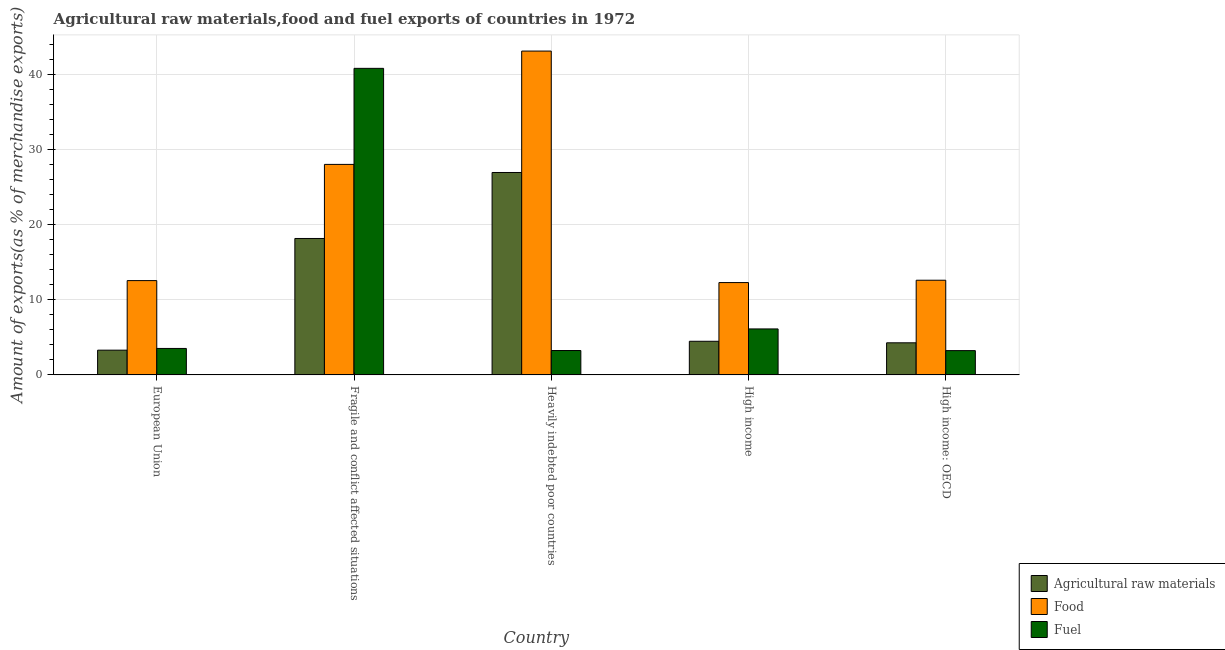How many different coloured bars are there?
Offer a terse response. 3. Are the number of bars per tick equal to the number of legend labels?
Offer a terse response. Yes. Are the number of bars on each tick of the X-axis equal?
Ensure brevity in your answer.  Yes. How many bars are there on the 4th tick from the right?
Your response must be concise. 3. What is the percentage of fuel exports in European Union?
Your response must be concise. 3.52. Across all countries, what is the maximum percentage of raw materials exports?
Your answer should be compact. 26.95. Across all countries, what is the minimum percentage of food exports?
Provide a succinct answer. 12.29. In which country was the percentage of food exports maximum?
Ensure brevity in your answer.  Heavily indebted poor countries. In which country was the percentage of raw materials exports minimum?
Your answer should be very brief. European Union. What is the total percentage of food exports in the graph?
Your response must be concise. 108.61. What is the difference between the percentage of fuel exports in European Union and that in Heavily indebted poor countries?
Provide a succinct answer. 0.28. What is the difference between the percentage of raw materials exports in European Union and the percentage of food exports in High income?
Give a very brief answer. -9. What is the average percentage of raw materials exports per country?
Your answer should be very brief. 11.43. What is the difference between the percentage of food exports and percentage of raw materials exports in High income: OECD?
Keep it short and to the point. 8.33. What is the ratio of the percentage of raw materials exports in Fragile and conflict affected situations to that in High income: OECD?
Your answer should be compact. 4.25. Is the difference between the percentage of raw materials exports in Fragile and conflict affected situations and High income: OECD greater than the difference between the percentage of food exports in Fragile and conflict affected situations and High income: OECD?
Provide a short and direct response. No. What is the difference between the highest and the second highest percentage of raw materials exports?
Offer a terse response. 8.79. What is the difference between the highest and the lowest percentage of fuel exports?
Your response must be concise. 37.59. Is the sum of the percentage of fuel exports in Heavily indebted poor countries and High income: OECD greater than the maximum percentage of food exports across all countries?
Provide a succinct answer. No. What does the 1st bar from the left in High income: OECD represents?
Ensure brevity in your answer.  Agricultural raw materials. What does the 3rd bar from the right in Fragile and conflict affected situations represents?
Provide a succinct answer. Agricultural raw materials. Is it the case that in every country, the sum of the percentage of raw materials exports and percentage of food exports is greater than the percentage of fuel exports?
Offer a terse response. Yes. Are all the bars in the graph horizontal?
Provide a short and direct response. No. Are the values on the major ticks of Y-axis written in scientific E-notation?
Offer a terse response. No. Does the graph contain any zero values?
Make the answer very short. No. Does the graph contain grids?
Ensure brevity in your answer.  Yes. Where does the legend appear in the graph?
Your answer should be compact. Bottom right. How many legend labels are there?
Keep it short and to the point. 3. What is the title of the graph?
Your response must be concise. Agricultural raw materials,food and fuel exports of countries in 1972. What is the label or title of the Y-axis?
Give a very brief answer. Amount of exports(as % of merchandise exports). What is the Amount of exports(as % of merchandise exports) of Agricultural raw materials in European Union?
Offer a very short reply. 3.3. What is the Amount of exports(as % of merchandise exports) in Food in European Union?
Provide a succinct answer. 12.56. What is the Amount of exports(as % of merchandise exports) in Fuel in European Union?
Provide a succinct answer. 3.52. What is the Amount of exports(as % of merchandise exports) of Agricultural raw materials in Fragile and conflict affected situations?
Ensure brevity in your answer.  18.17. What is the Amount of exports(as % of merchandise exports) of Food in Fragile and conflict affected situations?
Offer a very short reply. 28.03. What is the Amount of exports(as % of merchandise exports) in Fuel in Fragile and conflict affected situations?
Your response must be concise. 40.82. What is the Amount of exports(as % of merchandise exports) in Agricultural raw materials in Heavily indebted poor countries?
Provide a short and direct response. 26.95. What is the Amount of exports(as % of merchandise exports) in Food in Heavily indebted poor countries?
Offer a terse response. 43.12. What is the Amount of exports(as % of merchandise exports) in Fuel in Heavily indebted poor countries?
Your answer should be very brief. 3.25. What is the Amount of exports(as % of merchandise exports) of Agricultural raw materials in High income?
Ensure brevity in your answer.  4.48. What is the Amount of exports(as % of merchandise exports) in Food in High income?
Make the answer very short. 12.29. What is the Amount of exports(as % of merchandise exports) in Fuel in High income?
Offer a terse response. 6.12. What is the Amount of exports(as % of merchandise exports) in Agricultural raw materials in High income: OECD?
Your response must be concise. 4.27. What is the Amount of exports(as % of merchandise exports) of Food in High income: OECD?
Your answer should be very brief. 12.61. What is the Amount of exports(as % of merchandise exports) in Fuel in High income: OECD?
Your response must be concise. 3.24. Across all countries, what is the maximum Amount of exports(as % of merchandise exports) in Agricultural raw materials?
Provide a succinct answer. 26.95. Across all countries, what is the maximum Amount of exports(as % of merchandise exports) in Food?
Your answer should be compact. 43.12. Across all countries, what is the maximum Amount of exports(as % of merchandise exports) of Fuel?
Make the answer very short. 40.82. Across all countries, what is the minimum Amount of exports(as % of merchandise exports) in Agricultural raw materials?
Make the answer very short. 3.3. Across all countries, what is the minimum Amount of exports(as % of merchandise exports) of Food?
Offer a terse response. 12.29. Across all countries, what is the minimum Amount of exports(as % of merchandise exports) in Fuel?
Make the answer very short. 3.24. What is the total Amount of exports(as % of merchandise exports) of Agricultural raw materials in the graph?
Your answer should be compact. 57.17. What is the total Amount of exports(as % of merchandise exports) in Food in the graph?
Offer a very short reply. 108.61. What is the total Amount of exports(as % of merchandise exports) in Fuel in the graph?
Keep it short and to the point. 56.95. What is the difference between the Amount of exports(as % of merchandise exports) in Agricultural raw materials in European Union and that in Fragile and conflict affected situations?
Your answer should be compact. -14.87. What is the difference between the Amount of exports(as % of merchandise exports) in Food in European Union and that in Fragile and conflict affected situations?
Offer a very short reply. -15.47. What is the difference between the Amount of exports(as % of merchandise exports) of Fuel in European Union and that in Fragile and conflict affected situations?
Offer a very short reply. -37.3. What is the difference between the Amount of exports(as % of merchandise exports) of Agricultural raw materials in European Union and that in Heavily indebted poor countries?
Make the answer very short. -23.66. What is the difference between the Amount of exports(as % of merchandise exports) in Food in European Union and that in Heavily indebted poor countries?
Provide a succinct answer. -30.56. What is the difference between the Amount of exports(as % of merchandise exports) in Fuel in European Union and that in Heavily indebted poor countries?
Provide a short and direct response. 0.28. What is the difference between the Amount of exports(as % of merchandise exports) in Agricultural raw materials in European Union and that in High income?
Your answer should be compact. -1.18. What is the difference between the Amount of exports(as % of merchandise exports) in Food in European Union and that in High income?
Offer a very short reply. 0.26. What is the difference between the Amount of exports(as % of merchandise exports) of Fuel in European Union and that in High income?
Provide a short and direct response. -2.6. What is the difference between the Amount of exports(as % of merchandise exports) of Agricultural raw materials in European Union and that in High income: OECD?
Make the answer very short. -0.98. What is the difference between the Amount of exports(as % of merchandise exports) in Food in European Union and that in High income: OECD?
Keep it short and to the point. -0.05. What is the difference between the Amount of exports(as % of merchandise exports) of Fuel in European Union and that in High income: OECD?
Your response must be concise. 0.29. What is the difference between the Amount of exports(as % of merchandise exports) in Agricultural raw materials in Fragile and conflict affected situations and that in Heavily indebted poor countries?
Give a very brief answer. -8.79. What is the difference between the Amount of exports(as % of merchandise exports) of Food in Fragile and conflict affected situations and that in Heavily indebted poor countries?
Keep it short and to the point. -15.09. What is the difference between the Amount of exports(as % of merchandise exports) in Fuel in Fragile and conflict affected situations and that in Heavily indebted poor countries?
Offer a terse response. 37.57. What is the difference between the Amount of exports(as % of merchandise exports) of Agricultural raw materials in Fragile and conflict affected situations and that in High income?
Your answer should be very brief. 13.69. What is the difference between the Amount of exports(as % of merchandise exports) of Food in Fragile and conflict affected situations and that in High income?
Offer a very short reply. 15.74. What is the difference between the Amount of exports(as % of merchandise exports) of Fuel in Fragile and conflict affected situations and that in High income?
Offer a terse response. 34.7. What is the difference between the Amount of exports(as % of merchandise exports) of Agricultural raw materials in Fragile and conflict affected situations and that in High income: OECD?
Provide a short and direct response. 13.89. What is the difference between the Amount of exports(as % of merchandise exports) of Food in Fragile and conflict affected situations and that in High income: OECD?
Your answer should be very brief. 15.42. What is the difference between the Amount of exports(as % of merchandise exports) in Fuel in Fragile and conflict affected situations and that in High income: OECD?
Offer a very short reply. 37.59. What is the difference between the Amount of exports(as % of merchandise exports) in Agricultural raw materials in Heavily indebted poor countries and that in High income?
Offer a terse response. 22.47. What is the difference between the Amount of exports(as % of merchandise exports) in Food in Heavily indebted poor countries and that in High income?
Offer a terse response. 30.83. What is the difference between the Amount of exports(as % of merchandise exports) of Fuel in Heavily indebted poor countries and that in High income?
Provide a short and direct response. -2.88. What is the difference between the Amount of exports(as % of merchandise exports) of Agricultural raw materials in Heavily indebted poor countries and that in High income: OECD?
Offer a terse response. 22.68. What is the difference between the Amount of exports(as % of merchandise exports) in Food in Heavily indebted poor countries and that in High income: OECD?
Offer a terse response. 30.51. What is the difference between the Amount of exports(as % of merchandise exports) of Fuel in Heavily indebted poor countries and that in High income: OECD?
Your answer should be compact. 0.01. What is the difference between the Amount of exports(as % of merchandise exports) of Agricultural raw materials in High income and that in High income: OECD?
Your answer should be very brief. 0.2. What is the difference between the Amount of exports(as % of merchandise exports) in Food in High income and that in High income: OECD?
Keep it short and to the point. -0.31. What is the difference between the Amount of exports(as % of merchandise exports) of Fuel in High income and that in High income: OECD?
Your answer should be compact. 2.89. What is the difference between the Amount of exports(as % of merchandise exports) in Agricultural raw materials in European Union and the Amount of exports(as % of merchandise exports) in Food in Fragile and conflict affected situations?
Make the answer very short. -24.74. What is the difference between the Amount of exports(as % of merchandise exports) in Agricultural raw materials in European Union and the Amount of exports(as % of merchandise exports) in Fuel in Fragile and conflict affected situations?
Ensure brevity in your answer.  -37.52. What is the difference between the Amount of exports(as % of merchandise exports) of Food in European Union and the Amount of exports(as % of merchandise exports) of Fuel in Fragile and conflict affected situations?
Offer a very short reply. -28.26. What is the difference between the Amount of exports(as % of merchandise exports) in Agricultural raw materials in European Union and the Amount of exports(as % of merchandise exports) in Food in Heavily indebted poor countries?
Provide a short and direct response. -39.83. What is the difference between the Amount of exports(as % of merchandise exports) in Agricultural raw materials in European Union and the Amount of exports(as % of merchandise exports) in Fuel in Heavily indebted poor countries?
Provide a succinct answer. 0.05. What is the difference between the Amount of exports(as % of merchandise exports) of Food in European Union and the Amount of exports(as % of merchandise exports) of Fuel in Heavily indebted poor countries?
Make the answer very short. 9.31. What is the difference between the Amount of exports(as % of merchandise exports) in Agricultural raw materials in European Union and the Amount of exports(as % of merchandise exports) in Food in High income?
Make the answer very short. -9. What is the difference between the Amount of exports(as % of merchandise exports) of Agricultural raw materials in European Union and the Amount of exports(as % of merchandise exports) of Fuel in High income?
Offer a very short reply. -2.83. What is the difference between the Amount of exports(as % of merchandise exports) of Food in European Union and the Amount of exports(as % of merchandise exports) of Fuel in High income?
Your response must be concise. 6.43. What is the difference between the Amount of exports(as % of merchandise exports) in Agricultural raw materials in European Union and the Amount of exports(as % of merchandise exports) in Food in High income: OECD?
Keep it short and to the point. -9.31. What is the difference between the Amount of exports(as % of merchandise exports) of Agricultural raw materials in European Union and the Amount of exports(as % of merchandise exports) of Fuel in High income: OECD?
Provide a succinct answer. 0.06. What is the difference between the Amount of exports(as % of merchandise exports) of Food in European Union and the Amount of exports(as % of merchandise exports) of Fuel in High income: OECD?
Make the answer very short. 9.32. What is the difference between the Amount of exports(as % of merchandise exports) in Agricultural raw materials in Fragile and conflict affected situations and the Amount of exports(as % of merchandise exports) in Food in Heavily indebted poor countries?
Give a very brief answer. -24.95. What is the difference between the Amount of exports(as % of merchandise exports) of Agricultural raw materials in Fragile and conflict affected situations and the Amount of exports(as % of merchandise exports) of Fuel in Heavily indebted poor countries?
Your response must be concise. 14.92. What is the difference between the Amount of exports(as % of merchandise exports) of Food in Fragile and conflict affected situations and the Amount of exports(as % of merchandise exports) of Fuel in Heavily indebted poor countries?
Offer a very short reply. 24.78. What is the difference between the Amount of exports(as % of merchandise exports) of Agricultural raw materials in Fragile and conflict affected situations and the Amount of exports(as % of merchandise exports) of Food in High income?
Your answer should be compact. 5.87. What is the difference between the Amount of exports(as % of merchandise exports) of Agricultural raw materials in Fragile and conflict affected situations and the Amount of exports(as % of merchandise exports) of Fuel in High income?
Keep it short and to the point. 12.04. What is the difference between the Amount of exports(as % of merchandise exports) of Food in Fragile and conflict affected situations and the Amount of exports(as % of merchandise exports) of Fuel in High income?
Ensure brevity in your answer.  21.91. What is the difference between the Amount of exports(as % of merchandise exports) in Agricultural raw materials in Fragile and conflict affected situations and the Amount of exports(as % of merchandise exports) in Food in High income: OECD?
Provide a succinct answer. 5.56. What is the difference between the Amount of exports(as % of merchandise exports) of Agricultural raw materials in Fragile and conflict affected situations and the Amount of exports(as % of merchandise exports) of Fuel in High income: OECD?
Keep it short and to the point. 14.93. What is the difference between the Amount of exports(as % of merchandise exports) of Food in Fragile and conflict affected situations and the Amount of exports(as % of merchandise exports) of Fuel in High income: OECD?
Offer a terse response. 24.8. What is the difference between the Amount of exports(as % of merchandise exports) in Agricultural raw materials in Heavily indebted poor countries and the Amount of exports(as % of merchandise exports) in Food in High income?
Provide a succinct answer. 14.66. What is the difference between the Amount of exports(as % of merchandise exports) of Agricultural raw materials in Heavily indebted poor countries and the Amount of exports(as % of merchandise exports) of Fuel in High income?
Ensure brevity in your answer.  20.83. What is the difference between the Amount of exports(as % of merchandise exports) in Food in Heavily indebted poor countries and the Amount of exports(as % of merchandise exports) in Fuel in High income?
Make the answer very short. 37. What is the difference between the Amount of exports(as % of merchandise exports) in Agricultural raw materials in Heavily indebted poor countries and the Amount of exports(as % of merchandise exports) in Food in High income: OECD?
Provide a short and direct response. 14.35. What is the difference between the Amount of exports(as % of merchandise exports) in Agricultural raw materials in Heavily indebted poor countries and the Amount of exports(as % of merchandise exports) in Fuel in High income: OECD?
Offer a terse response. 23.72. What is the difference between the Amount of exports(as % of merchandise exports) of Food in Heavily indebted poor countries and the Amount of exports(as % of merchandise exports) of Fuel in High income: OECD?
Provide a short and direct response. 39.89. What is the difference between the Amount of exports(as % of merchandise exports) of Agricultural raw materials in High income and the Amount of exports(as % of merchandise exports) of Food in High income: OECD?
Offer a very short reply. -8.13. What is the difference between the Amount of exports(as % of merchandise exports) in Agricultural raw materials in High income and the Amount of exports(as % of merchandise exports) in Fuel in High income: OECD?
Your answer should be compact. 1.24. What is the difference between the Amount of exports(as % of merchandise exports) of Food in High income and the Amount of exports(as % of merchandise exports) of Fuel in High income: OECD?
Your answer should be very brief. 9.06. What is the average Amount of exports(as % of merchandise exports) in Agricultural raw materials per country?
Offer a very short reply. 11.43. What is the average Amount of exports(as % of merchandise exports) of Food per country?
Offer a terse response. 21.72. What is the average Amount of exports(as % of merchandise exports) of Fuel per country?
Give a very brief answer. 11.39. What is the difference between the Amount of exports(as % of merchandise exports) of Agricultural raw materials and Amount of exports(as % of merchandise exports) of Food in European Union?
Offer a very short reply. -9.26. What is the difference between the Amount of exports(as % of merchandise exports) of Agricultural raw materials and Amount of exports(as % of merchandise exports) of Fuel in European Union?
Make the answer very short. -0.23. What is the difference between the Amount of exports(as % of merchandise exports) of Food and Amount of exports(as % of merchandise exports) of Fuel in European Union?
Keep it short and to the point. 9.03. What is the difference between the Amount of exports(as % of merchandise exports) in Agricultural raw materials and Amount of exports(as % of merchandise exports) in Food in Fragile and conflict affected situations?
Make the answer very short. -9.86. What is the difference between the Amount of exports(as % of merchandise exports) in Agricultural raw materials and Amount of exports(as % of merchandise exports) in Fuel in Fragile and conflict affected situations?
Your answer should be compact. -22.65. What is the difference between the Amount of exports(as % of merchandise exports) in Food and Amount of exports(as % of merchandise exports) in Fuel in Fragile and conflict affected situations?
Ensure brevity in your answer.  -12.79. What is the difference between the Amount of exports(as % of merchandise exports) in Agricultural raw materials and Amount of exports(as % of merchandise exports) in Food in Heavily indebted poor countries?
Offer a terse response. -16.17. What is the difference between the Amount of exports(as % of merchandise exports) of Agricultural raw materials and Amount of exports(as % of merchandise exports) of Fuel in Heavily indebted poor countries?
Provide a succinct answer. 23.71. What is the difference between the Amount of exports(as % of merchandise exports) of Food and Amount of exports(as % of merchandise exports) of Fuel in Heavily indebted poor countries?
Ensure brevity in your answer.  39.87. What is the difference between the Amount of exports(as % of merchandise exports) in Agricultural raw materials and Amount of exports(as % of merchandise exports) in Food in High income?
Keep it short and to the point. -7.82. What is the difference between the Amount of exports(as % of merchandise exports) of Agricultural raw materials and Amount of exports(as % of merchandise exports) of Fuel in High income?
Your answer should be compact. -1.65. What is the difference between the Amount of exports(as % of merchandise exports) of Food and Amount of exports(as % of merchandise exports) of Fuel in High income?
Your answer should be very brief. 6.17. What is the difference between the Amount of exports(as % of merchandise exports) of Agricultural raw materials and Amount of exports(as % of merchandise exports) of Food in High income: OECD?
Make the answer very short. -8.33. What is the difference between the Amount of exports(as % of merchandise exports) of Agricultural raw materials and Amount of exports(as % of merchandise exports) of Fuel in High income: OECD?
Your answer should be compact. 1.04. What is the difference between the Amount of exports(as % of merchandise exports) of Food and Amount of exports(as % of merchandise exports) of Fuel in High income: OECD?
Offer a very short reply. 9.37. What is the ratio of the Amount of exports(as % of merchandise exports) of Agricultural raw materials in European Union to that in Fragile and conflict affected situations?
Make the answer very short. 0.18. What is the ratio of the Amount of exports(as % of merchandise exports) in Food in European Union to that in Fragile and conflict affected situations?
Keep it short and to the point. 0.45. What is the ratio of the Amount of exports(as % of merchandise exports) of Fuel in European Union to that in Fragile and conflict affected situations?
Your answer should be compact. 0.09. What is the ratio of the Amount of exports(as % of merchandise exports) in Agricultural raw materials in European Union to that in Heavily indebted poor countries?
Your answer should be very brief. 0.12. What is the ratio of the Amount of exports(as % of merchandise exports) of Food in European Union to that in Heavily indebted poor countries?
Your response must be concise. 0.29. What is the ratio of the Amount of exports(as % of merchandise exports) in Fuel in European Union to that in Heavily indebted poor countries?
Offer a very short reply. 1.09. What is the ratio of the Amount of exports(as % of merchandise exports) in Agricultural raw materials in European Union to that in High income?
Offer a very short reply. 0.74. What is the ratio of the Amount of exports(as % of merchandise exports) of Food in European Union to that in High income?
Provide a short and direct response. 1.02. What is the ratio of the Amount of exports(as % of merchandise exports) of Fuel in European Union to that in High income?
Give a very brief answer. 0.58. What is the ratio of the Amount of exports(as % of merchandise exports) in Agricultural raw materials in European Union to that in High income: OECD?
Your response must be concise. 0.77. What is the ratio of the Amount of exports(as % of merchandise exports) in Food in European Union to that in High income: OECD?
Make the answer very short. 1. What is the ratio of the Amount of exports(as % of merchandise exports) in Fuel in European Union to that in High income: OECD?
Make the answer very short. 1.09. What is the ratio of the Amount of exports(as % of merchandise exports) of Agricultural raw materials in Fragile and conflict affected situations to that in Heavily indebted poor countries?
Provide a succinct answer. 0.67. What is the ratio of the Amount of exports(as % of merchandise exports) of Food in Fragile and conflict affected situations to that in Heavily indebted poor countries?
Give a very brief answer. 0.65. What is the ratio of the Amount of exports(as % of merchandise exports) in Fuel in Fragile and conflict affected situations to that in Heavily indebted poor countries?
Ensure brevity in your answer.  12.57. What is the ratio of the Amount of exports(as % of merchandise exports) of Agricultural raw materials in Fragile and conflict affected situations to that in High income?
Your answer should be compact. 4.06. What is the ratio of the Amount of exports(as % of merchandise exports) in Food in Fragile and conflict affected situations to that in High income?
Give a very brief answer. 2.28. What is the ratio of the Amount of exports(as % of merchandise exports) of Fuel in Fragile and conflict affected situations to that in High income?
Keep it short and to the point. 6.67. What is the ratio of the Amount of exports(as % of merchandise exports) of Agricultural raw materials in Fragile and conflict affected situations to that in High income: OECD?
Keep it short and to the point. 4.25. What is the ratio of the Amount of exports(as % of merchandise exports) in Food in Fragile and conflict affected situations to that in High income: OECD?
Keep it short and to the point. 2.22. What is the ratio of the Amount of exports(as % of merchandise exports) in Fuel in Fragile and conflict affected situations to that in High income: OECD?
Keep it short and to the point. 12.62. What is the ratio of the Amount of exports(as % of merchandise exports) of Agricultural raw materials in Heavily indebted poor countries to that in High income?
Provide a succinct answer. 6.02. What is the ratio of the Amount of exports(as % of merchandise exports) of Food in Heavily indebted poor countries to that in High income?
Offer a very short reply. 3.51. What is the ratio of the Amount of exports(as % of merchandise exports) of Fuel in Heavily indebted poor countries to that in High income?
Offer a terse response. 0.53. What is the ratio of the Amount of exports(as % of merchandise exports) in Agricultural raw materials in Heavily indebted poor countries to that in High income: OECD?
Keep it short and to the point. 6.31. What is the ratio of the Amount of exports(as % of merchandise exports) in Food in Heavily indebted poor countries to that in High income: OECD?
Your response must be concise. 3.42. What is the ratio of the Amount of exports(as % of merchandise exports) of Agricultural raw materials in High income to that in High income: OECD?
Offer a very short reply. 1.05. What is the ratio of the Amount of exports(as % of merchandise exports) in Food in High income to that in High income: OECD?
Keep it short and to the point. 0.98. What is the ratio of the Amount of exports(as % of merchandise exports) in Fuel in High income to that in High income: OECD?
Your response must be concise. 1.89. What is the difference between the highest and the second highest Amount of exports(as % of merchandise exports) in Agricultural raw materials?
Offer a very short reply. 8.79. What is the difference between the highest and the second highest Amount of exports(as % of merchandise exports) in Food?
Your answer should be compact. 15.09. What is the difference between the highest and the second highest Amount of exports(as % of merchandise exports) in Fuel?
Your answer should be compact. 34.7. What is the difference between the highest and the lowest Amount of exports(as % of merchandise exports) of Agricultural raw materials?
Ensure brevity in your answer.  23.66. What is the difference between the highest and the lowest Amount of exports(as % of merchandise exports) of Food?
Your answer should be very brief. 30.83. What is the difference between the highest and the lowest Amount of exports(as % of merchandise exports) of Fuel?
Keep it short and to the point. 37.59. 